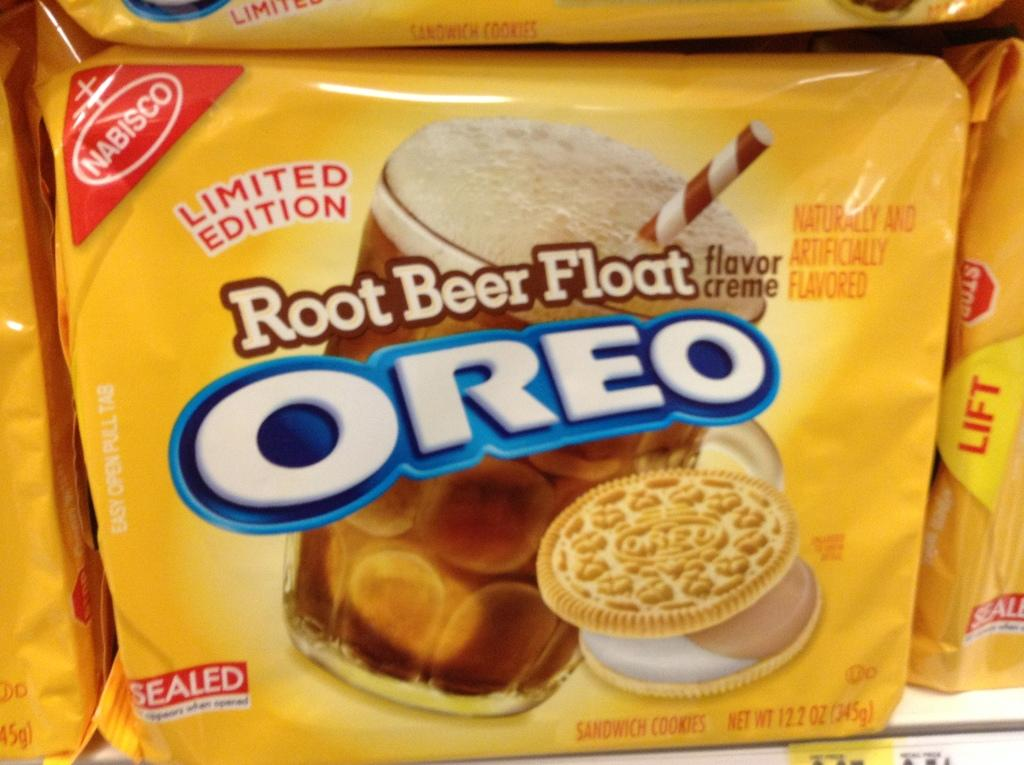What is contained within the packet in the image? The packet contains a glass and biscuits. What else can be found on the packet? There is text on the packet. Is there a volcano erupting in the background of the image? No, there is no volcano or any indication of a volcanic eruption in the image. 